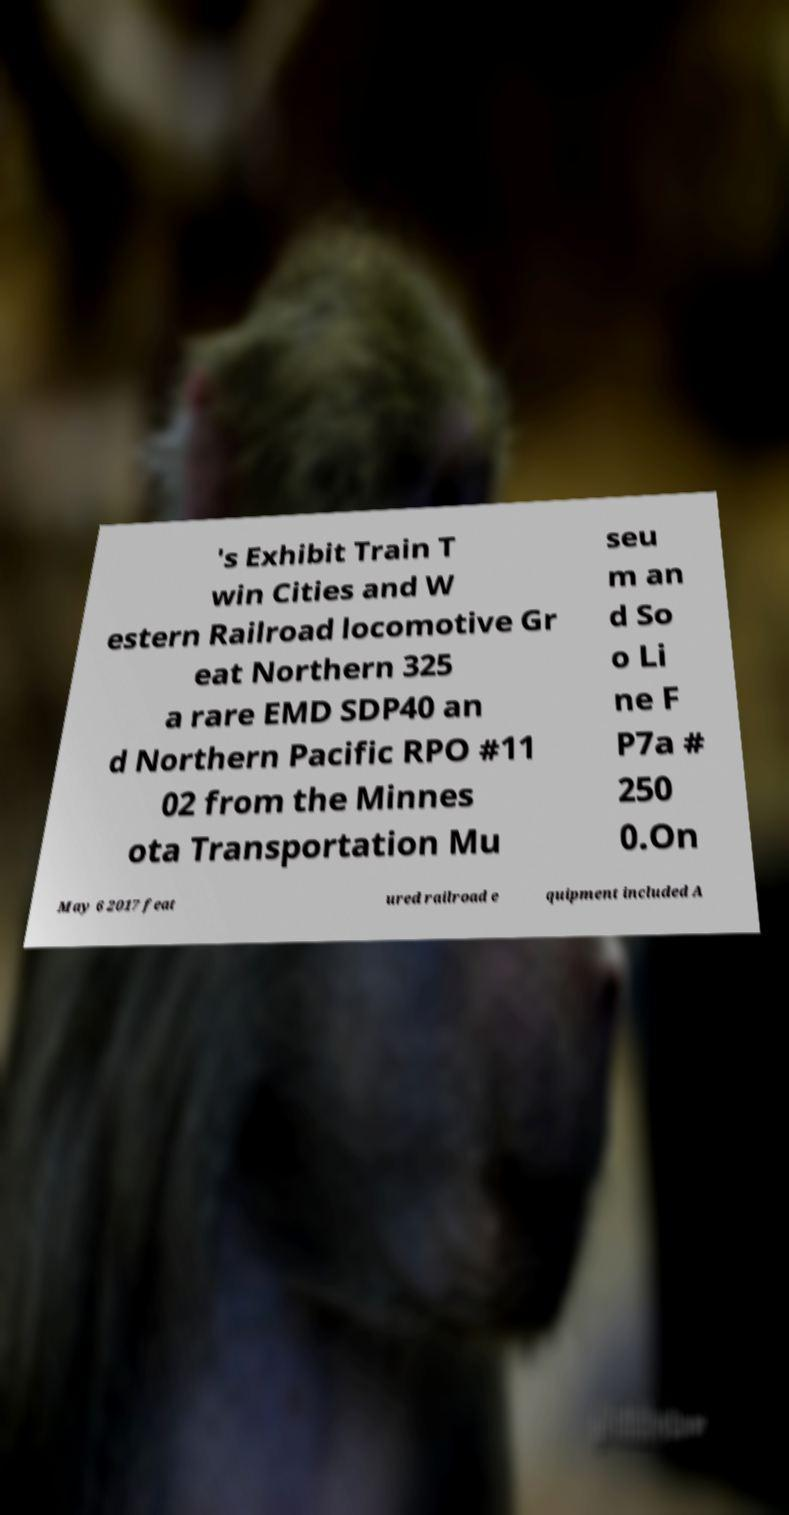Please identify and transcribe the text found in this image. 's Exhibit Train T win Cities and W estern Railroad locomotive Gr eat Northern 325 a rare EMD SDP40 an d Northern Pacific RPO #11 02 from the Minnes ota Transportation Mu seu m an d So o Li ne F P7a # 250 0.On May 6 2017 feat ured railroad e quipment included A 